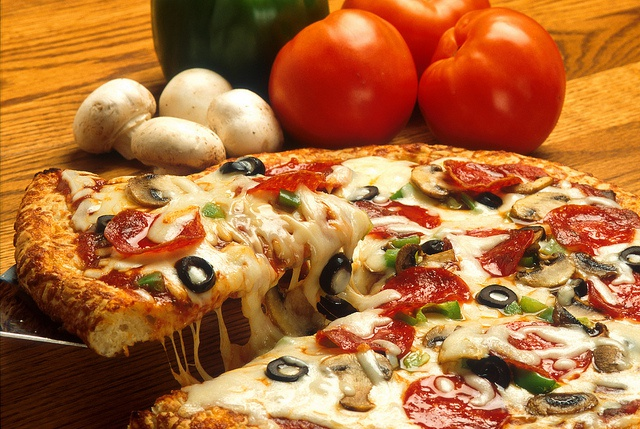Describe the objects in this image and their specific colors. I can see dining table in black, orange, brown, and tan tones, pizza in olive, tan, brown, and beige tones, and knife in olive, black, maroon, and ivory tones in this image. 